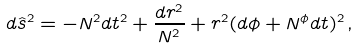Convert formula to latex. <formula><loc_0><loc_0><loc_500><loc_500>d { \hat { s } } ^ { 2 } = - N ^ { 2 } d t ^ { 2 } + \frac { d r ^ { 2 } } { N ^ { 2 } } + r ^ { 2 } ( d \phi + N ^ { \phi } d t ) ^ { 2 } \, ,</formula> 